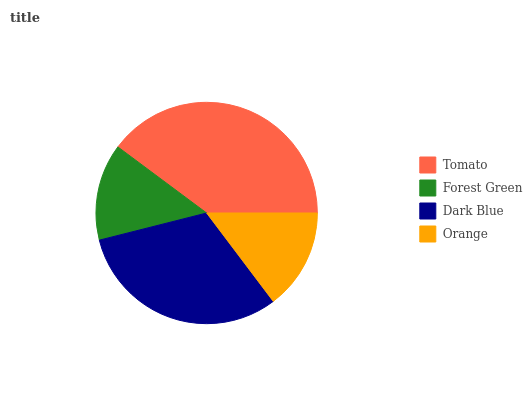Is Forest Green the minimum?
Answer yes or no. Yes. Is Tomato the maximum?
Answer yes or no. Yes. Is Dark Blue the minimum?
Answer yes or no. No. Is Dark Blue the maximum?
Answer yes or no. No. Is Dark Blue greater than Forest Green?
Answer yes or no. Yes. Is Forest Green less than Dark Blue?
Answer yes or no. Yes. Is Forest Green greater than Dark Blue?
Answer yes or no. No. Is Dark Blue less than Forest Green?
Answer yes or no. No. Is Dark Blue the high median?
Answer yes or no. Yes. Is Orange the low median?
Answer yes or no. Yes. Is Tomato the high median?
Answer yes or no. No. Is Dark Blue the low median?
Answer yes or no. No. 